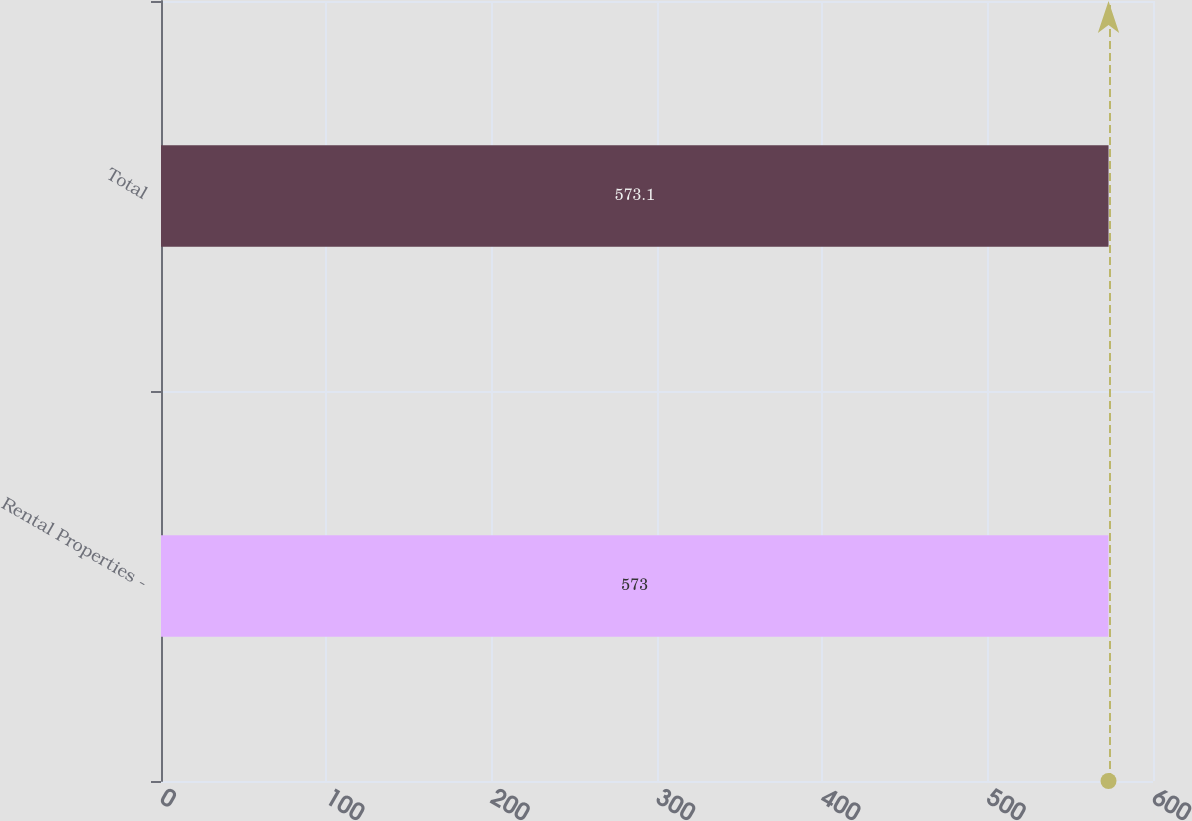<chart> <loc_0><loc_0><loc_500><loc_500><bar_chart><fcel>Rental Properties -<fcel>Total<nl><fcel>573<fcel>573.1<nl></chart> 